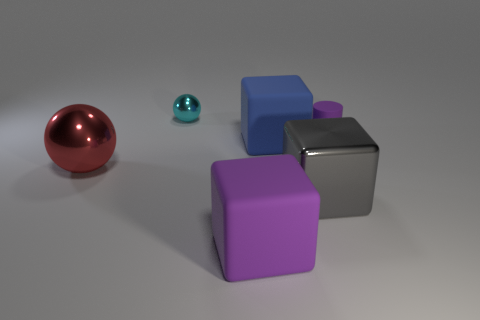Subtract all shiny cubes. How many cubes are left? 2 Subtract all gray blocks. How many blocks are left? 2 Add 4 large blue cubes. How many objects exist? 10 Subtract all cylinders. How many objects are left? 5 Subtract 2 spheres. How many spheres are left? 0 Subtract all brown spheres. Subtract all cyan cylinders. How many spheres are left? 2 Subtract all purple spheres. How many blue cylinders are left? 0 Subtract all gray matte objects. Subtract all tiny matte cylinders. How many objects are left? 5 Add 3 small shiny things. How many small shiny things are left? 4 Add 4 big matte blocks. How many big matte blocks exist? 6 